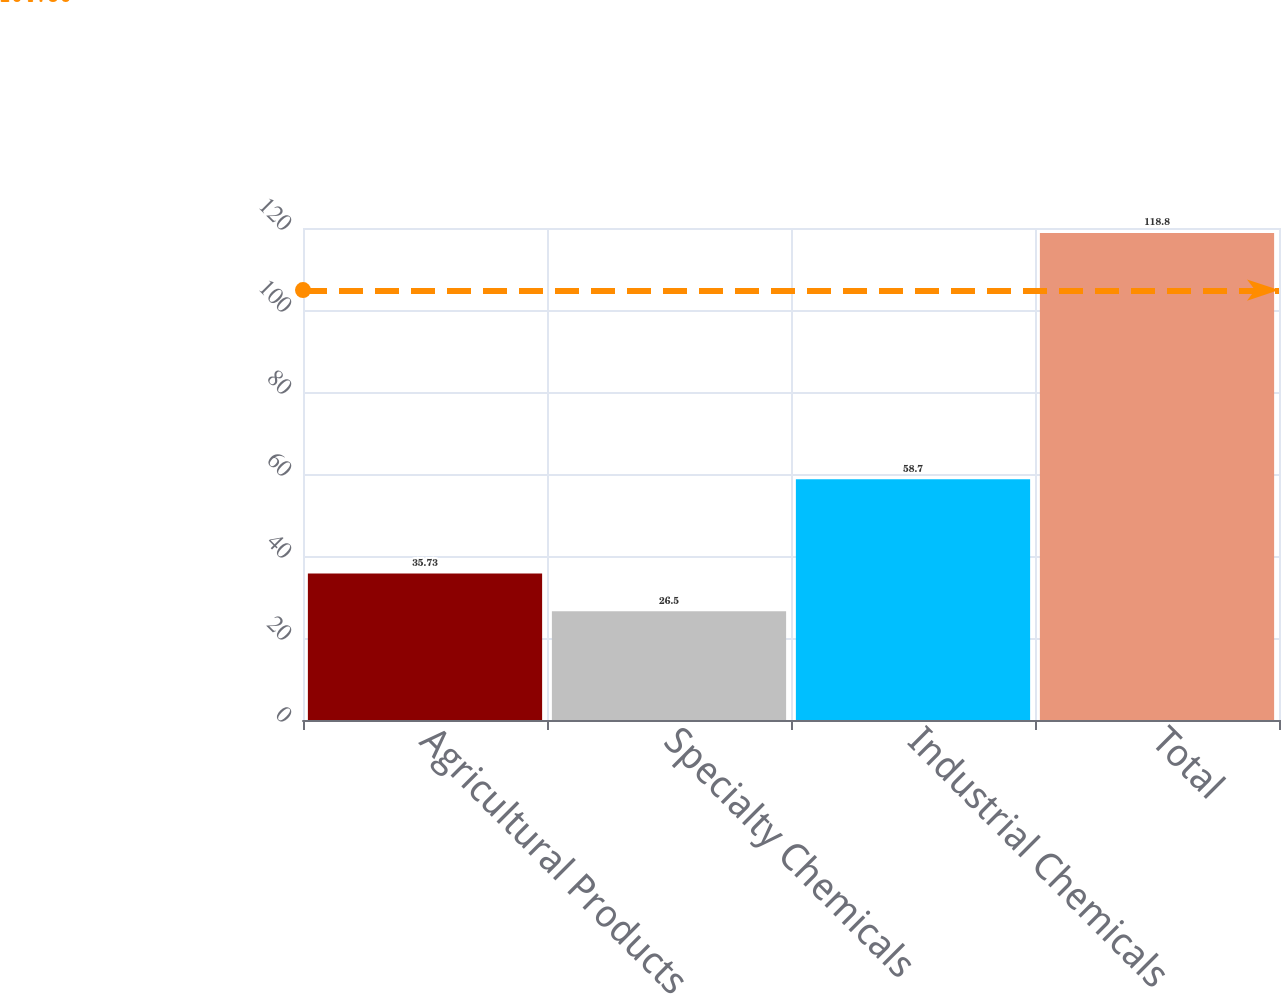Convert chart to OTSL. <chart><loc_0><loc_0><loc_500><loc_500><bar_chart><fcel>Agricultural Products<fcel>Specialty Chemicals<fcel>Industrial Chemicals<fcel>Total<nl><fcel>35.73<fcel>26.5<fcel>58.7<fcel>118.8<nl></chart> 